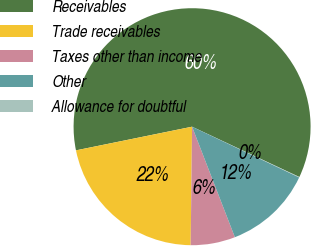Convert chart. <chart><loc_0><loc_0><loc_500><loc_500><pie_chart><fcel>Receivables<fcel>Trade receivables<fcel>Taxes other than income<fcel>Other<fcel>Allowance for doubtful<nl><fcel>60.18%<fcel>21.61%<fcel>6.07%<fcel>12.08%<fcel>0.06%<nl></chart> 